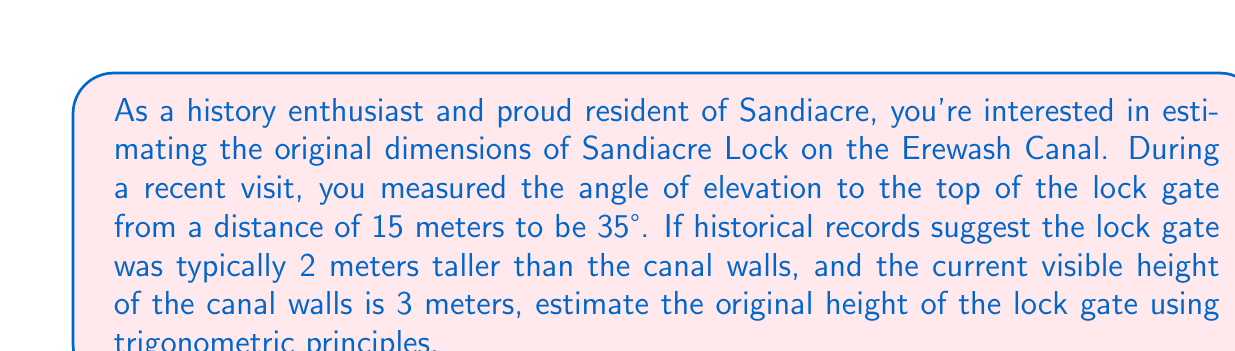Help me with this question. To solve this problem, we'll use trigonometric ratios, specifically the tangent function. Let's break it down step-by-step:

1) First, let's visualize the scenario:

[asy]
import geometry;

size(200);
pair A = (0,0), B = (15,0), C = (15,10.5);
draw(A--B--C--A);
label("15m", (7.5,0), S);
label("35°", A, SW);
label("x", (15,5), E);
draw(rightangle(A,B,C,2));
[/asy]

2) In this right-angled triangle, we know:
   - The adjacent side (distance from observer to lock) = 15 meters
   - The angle of elevation = 35°
   - We need to find the opposite side (height of the lock gate)

3) We can use the tangent ratio:

   $$\tan(\theta) = \frac{\text{opposite}}{\text{adjacent}}$$

4) Substituting our known values:

   $$\tan(35°) = \frac{x}{15}$$

5) Solving for x:

   $$x = 15 \tan(35°)$$

6) Using a calculator or trigonometric tables:

   $$x \approx 15 \times 0.7002 \approx 10.503 \text{ meters}$$

7) This is the total height from the ground to the top of the lock gate. To find the original height of the lock gate:
   - Subtract the current visible height of the canal walls: 10.503 - 3 = 7.503 meters
   - Add the typical 2 meters that the gate extended above the walls: 7.503 + 2 = 9.503 meters

Therefore, the estimated original height of the lock gate is approximately 9.5 meters.
Answer: The estimated original height of the Sandiacre Lock gate on the Erewash Canal is approximately 9.5 meters. 